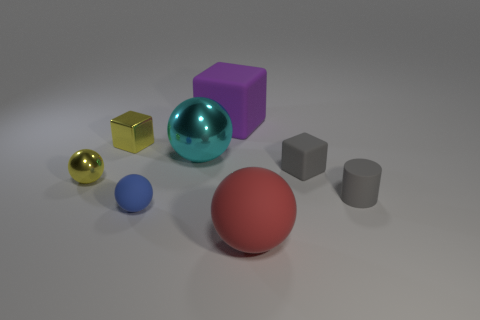Subtract all brown balls. Subtract all cyan blocks. How many balls are left? 4 Add 1 red objects. How many objects exist? 9 Subtract all cylinders. How many objects are left? 7 Add 3 brown shiny things. How many brown shiny things exist? 3 Subtract 1 red balls. How many objects are left? 7 Subtract all large yellow cubes. Subtract all red rubber spheres. How many objects are left? 7 Add 7 purple matte things. How many purple matte things are left? 8 